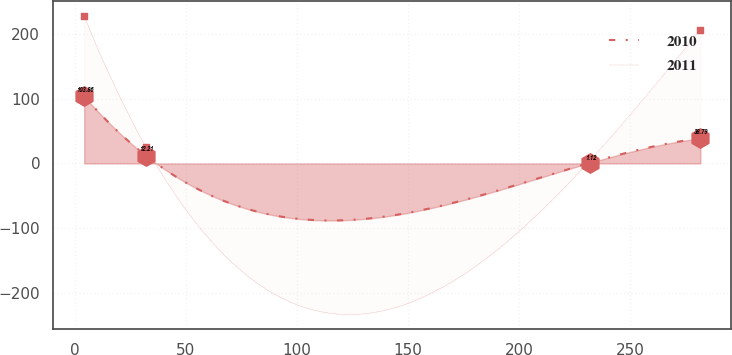Convert chart to OTSL. <chart><loc_0><loc_0><loc_500><loc_500><line_chart><ecel><fcel>2010<fcel>2011<nl><fcel>4.24<fcel>103.86<fcel>227.78<nl><fcel>31.99<fcel>12.21<fcel>25.68<nl><fcel>232.12<fcel>1.12<fcel>4.97<nl><fcel>281.76<fcel>38.79<fcel>207.07<nl></chart> 